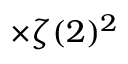Convert formula to latex. <formula><loc_0><loc_0><loc_500><loc_500>\times \zeta ( 2 ) ^ { 2 }</formula> 